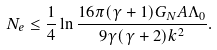Convert formula to latex. <formula><loc_0><loc_0><loc_500><loc_500>N _ { e } \leq \frac { 1 } { 4 } \ln \frac { 1 6 \pi ( \gamma + 1 ) G _ { N } A \Lambda _ { 0 } } { 9 \gamma ( \gamma + 2 ) k ^ { 2 } } .</formula> 